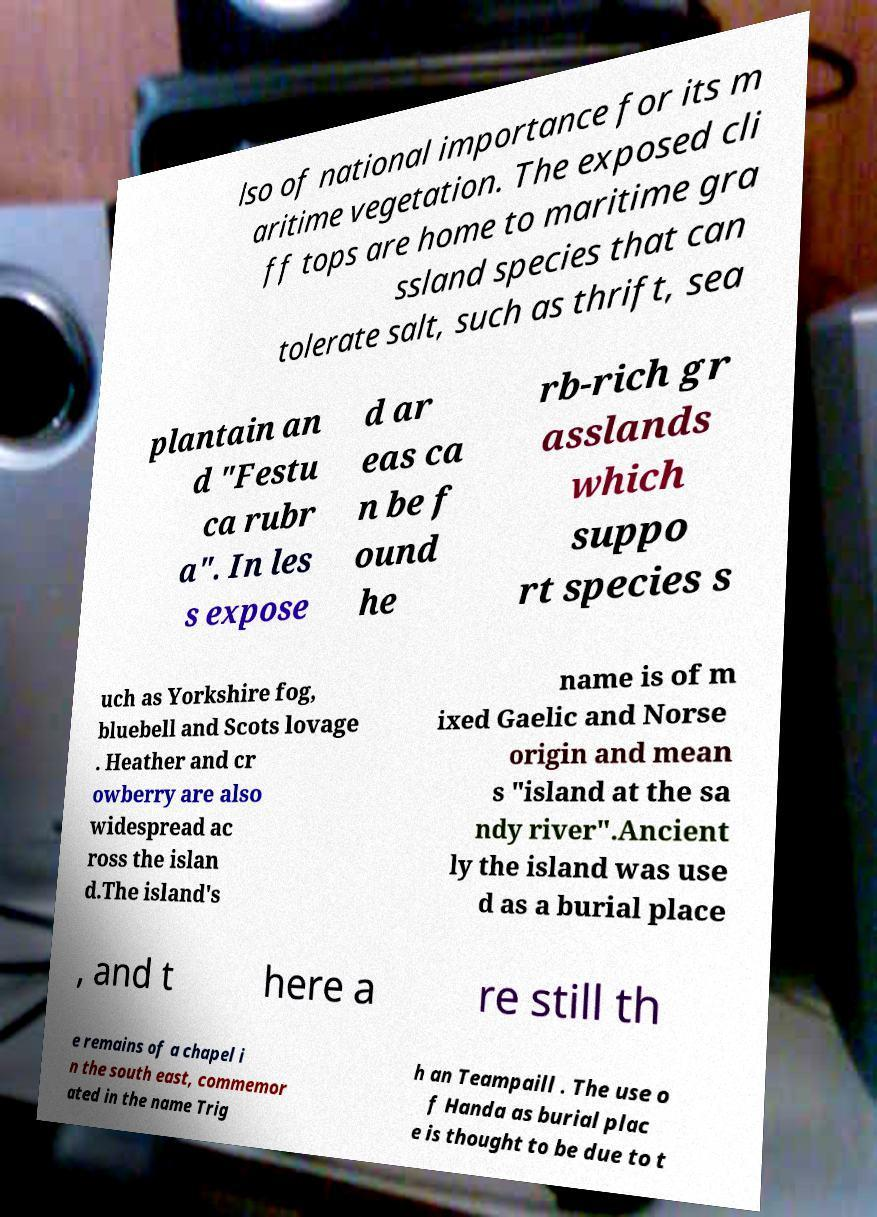Could you assist in decoding the text presented in this image and type it out clearly? lso of national importance for its m aritime vegetation. The exposed cli ff tops are home to maritime gra ssland species that can tolerate salt, such as thrift, sea plantain an d "Festu ca rubr a". In les s expose d ar eas ca n be f ound he rb-rich gr asslands which suppo rt species s uch as Yorkshire fog, bluebell and Scots lovage . Heather and cr owberry are also widespread ac ross the islan d.The island's name is of m ixed Gaelic and Norse origin and mean s "island at the sa ndy river".Ancient ly the island was use d as a burial place , and t here a re still th e remains of a chapel i n the south east, commemor ated in the name Trig h an Teampaill . The use o f Handa as burial plac e is thought to be due to t 